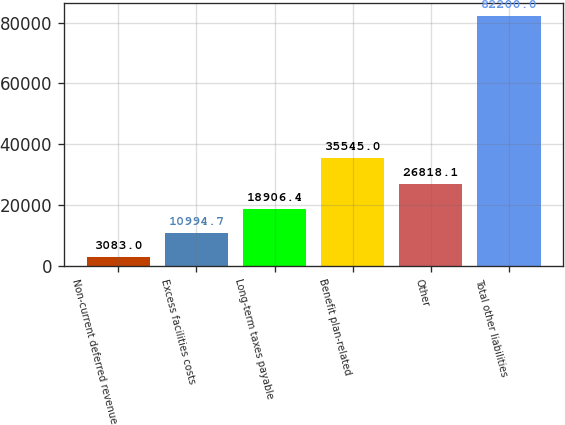<chart> <loc_0><loc_0><loc_500><loc_500><bar_chart><fcel>Non-current deferred revenue<fcel>Excess facilities costs<fcel>Long-term taxes payable<fcel>Benefit plan-related<fcel>Other<fcel>Total other liabilities<nl><fcel>3083<fcel>10994.7<fcel>18906.4<fcel>35545<fcel>26818.1<fcel>82200<nl></chart> 